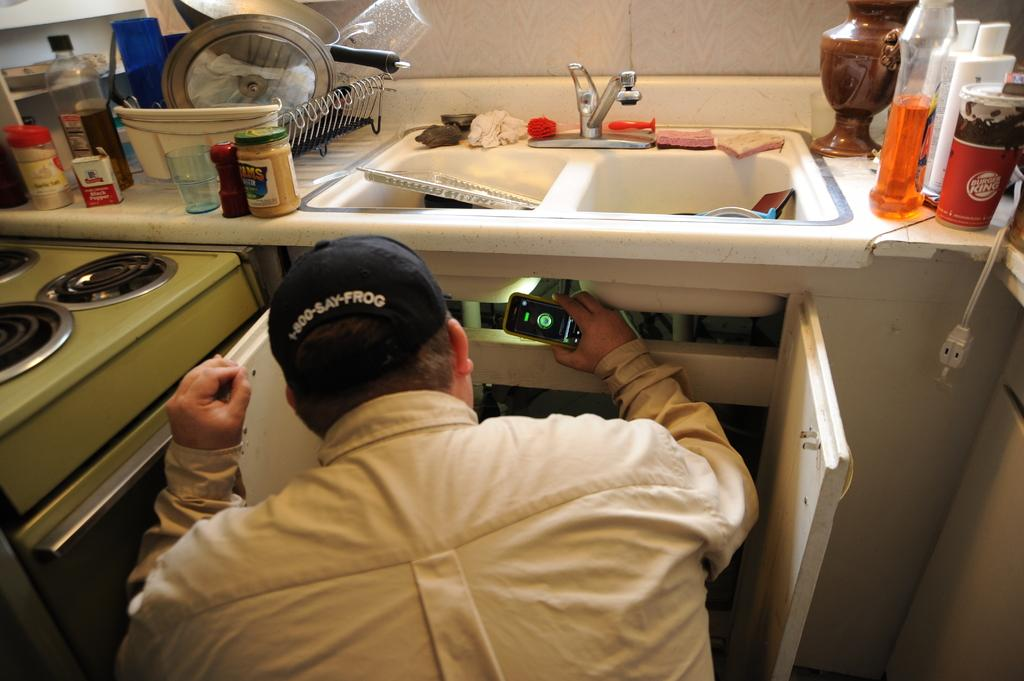<image>
Provide a brief description of the given image. Man looking under the sink that has a Burger King soda on top. 